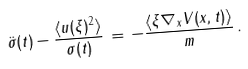Convert formula to latex. <formula><loc_0><loc_0><loc_500><loc_500>\ddot { \sigma } ( t ) - \frac { \langle u ( \xi ) ^ { 2 } \rangle } { \sigma ( t ) } \, = \, - \frac { \langle \xi \nabla _ { x } V ( x , t ) \rangle } { m } \, .</formula> 